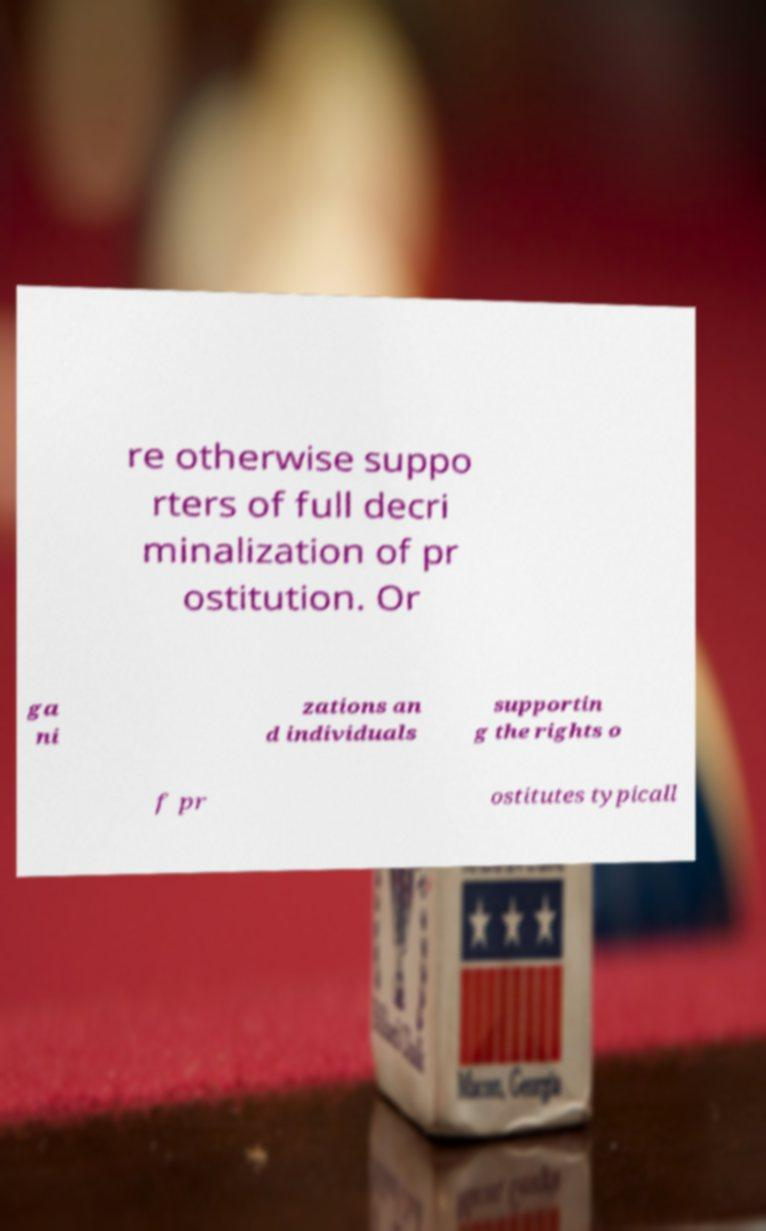Please read and relay the text visible in this image. What does it say? re otherwise suppo rters of full decri minalization of pr ostitution. Or ga ni zations an d individuals supportin g the rights o f pr ostitutes typicall 